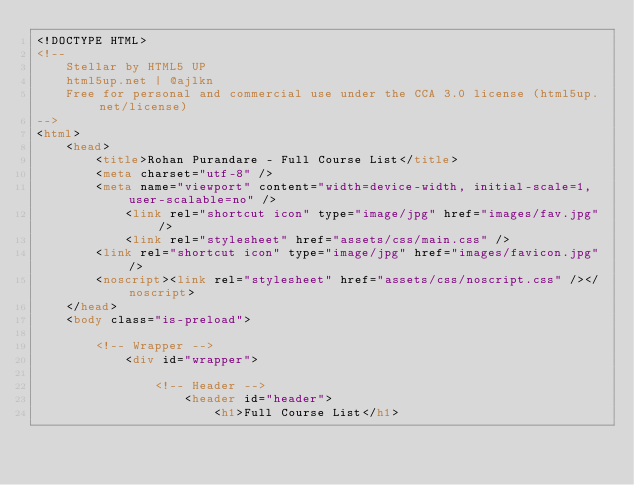Convert code to text. <code><loc_0><loc_0><loc_500><loc_500><_HTML_><!DOCTYPE HTML>
<!--
	Stellar by HTML5 UP
	html5up.net | @ajlkn
	Free for personal and commercial use under the CCA 3.0 license (html5up.net/license)
-->
<html>
	<head>
		<title>Rohan Purandare - Full Course List</title>
		<meta charset="utf-8" />
		<meta name="viewport" content="width=device-width, initial-scale=1, user-scalable=no" />
        	<link rel="shortcut icon" type="image/jpg" href="images/fav.jpg"/>
        	<link rel="stylesheet" href="assets/css/main.css" />
		<link rel="shortcut icon" type="image/jpg" href="images/favicon.jpg"/>
		<noscript><link rel="stylesheet" href="assets/css/noscript.css" /></noscript>
	</head>
	<body class="is-preload">

		<!-- Wrapper -->
			<div id="wrapper">

				<!-- Header -->
					<header id="header">
						<h1>Full Course List</h1></code> 